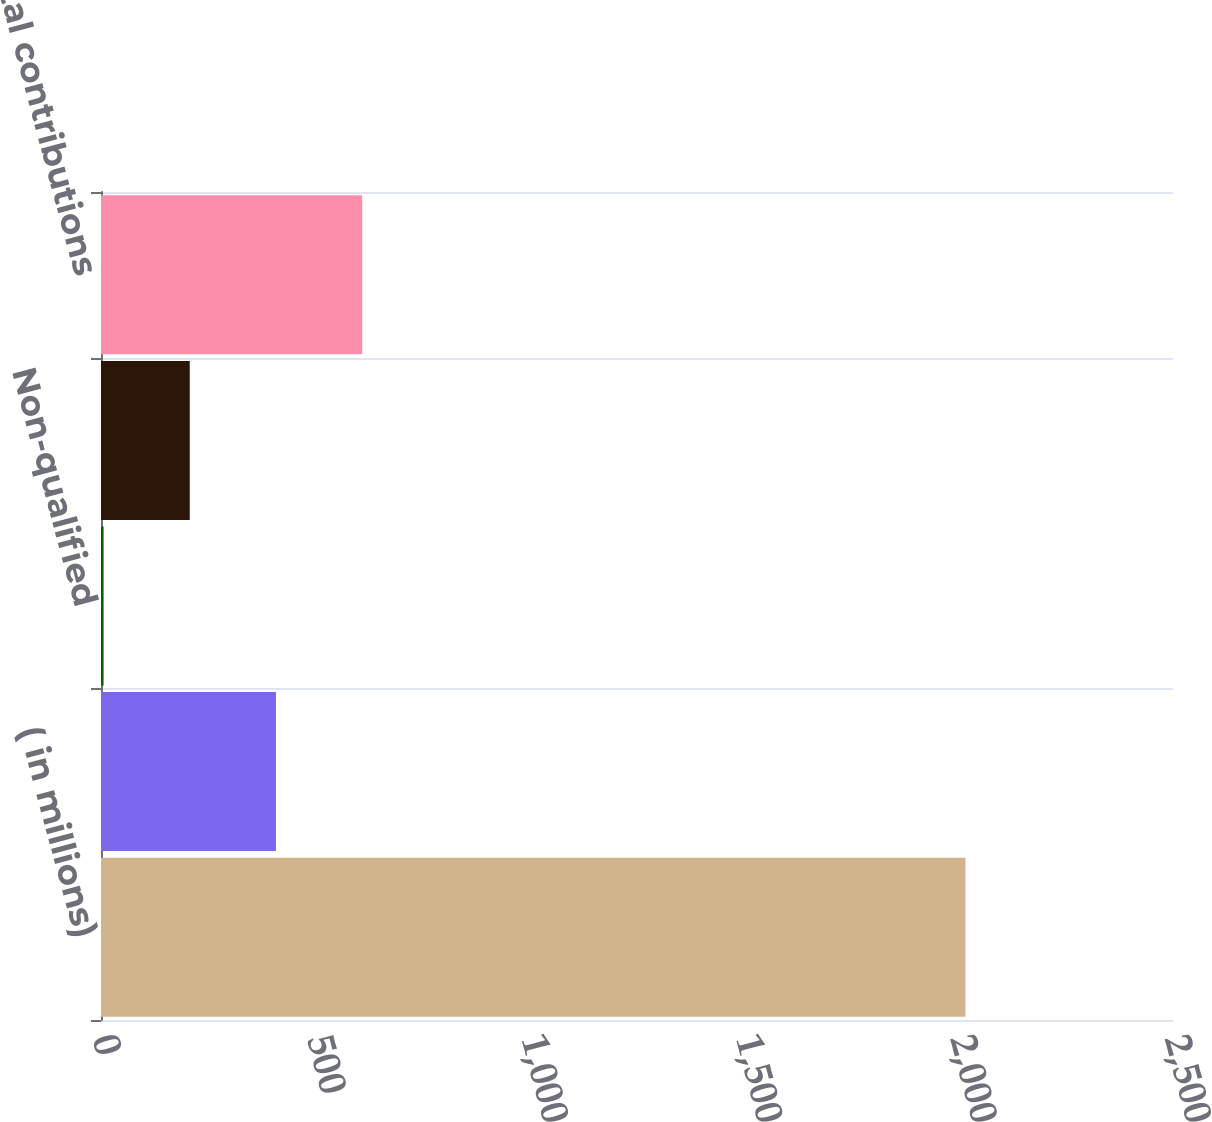Convert chart to OTSL. <chart><loc_0><loc_0><loc_500><loc_500><bar_chart><fcel>( in millions)<fcel>Qualified<fcel>Non-qualified<fcel>Other benefit plans<fcel>Total contributions<nl><fcel>2016<fcel>408<fcel>6<fcel>207<fcel>609<nl></chart> 